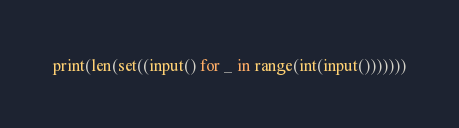<code> <loc_0><loc_0><loc_500><loc_500><_Python_>print(len(set((input() for _ in range(int(input()))))))</code> 